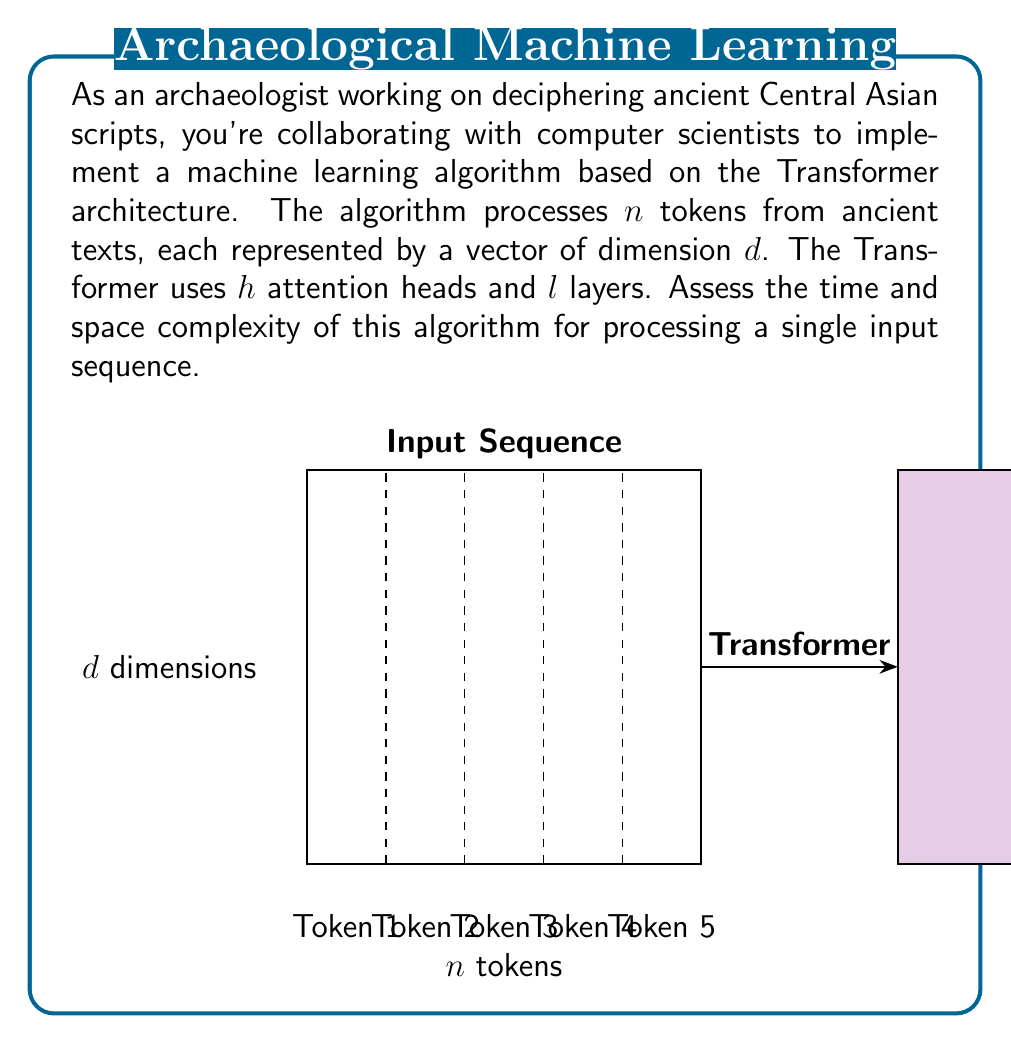Teach me how to tackle this problem. Let's break down the complexity analysis step by step:

1) Self-Attention Mechanism:
   - For each token, we compute attention scores with all other tokens.
   - This requires $O(n^2)$ operations for $n$ tokens.
   - We do this for $d$ dimensions and $h$ heads.
   - Time complexity for one layer: $O(n^2hd)$

2) Feed-Forward Neural Network:
   - Each token goes through a feedforward network.
   - This is typically $O(d^2)$ operations per token.
   - Time complexity for one layer: $O(nd^2)$

3) Layer Normalization and Residual Connections:
   - These operations are linear in the number of tokens and dimensions.
   - Time complexity for one layer: $O(nd)$

4) Total Time Complexity:
   - We have $l$ layers, each performing steps 1-3.
   - Total time complexity: $O(l(n^2hd + nd^2 + nd)) = O(ln^2hd + lnd^2)$

5) Space Complexity:
   - We need to store the input sequence: $O(nd)$
   - Attention matrices for each head: $O(hn^2)$
   - Model parameters (primarily in feed-forward layers): $O(ld^2)$
   - Total space complexity: $O(nd + hn^2 + ld^2)$

The dominant terms in the complexities depend on the relative sizes of $n$, $d$, $h$, and $l$. For typical Transformer models, $d$ and $h$ are constants, while $n$ can vary widely depending on the input sequence length.
Answer: Time complexity: $O(ln^2hd + lnd^2)$; Space complexity: $O(nd + hn^2 + ld^2)$ 